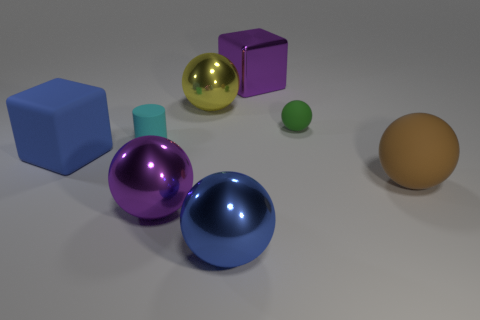Subtract all brown balls. How many balls are left? 4 Add 1 large yellow metal cylinders. How many objects exist? 9 Subtract all purple balls. How many balls are left? 4 Subtract all blocks. How many objects are left? 6 Subtract all green cubes. Subtract all cyan spheres. How many cubes are left? 2 Add 2 large matte things. How many large matte things exist? 4 Subtract 1 purple cubes. How many objects are left? 7 Subtract all green matte things. Subtract all cylinders. How many objects are left? 6 Add 4 big yellow metal spheres. How many big yellow metal spheres are left? 5 